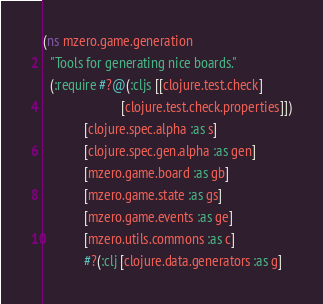<code> <loc_0><loc_0><loc_500><loc_500><_Clojure_>(ns mzero.game.generation
  "Tools for generating nice boards."
  (:require #?@(:cljs [[clojure.test.check]
                       [clojure.test.check.properties]])
            [clojure.spec.alpha :as s]
            [clojure.spec.gen.alpha :as gen]
            [mzero.game.board :as gb]
            [mzero.game.state :as gs]
            [mzero.game.events :as ge]
            [mzero.utils.commons :as c]
            #?(:clj [clojure.data.generators :as g]</code> 